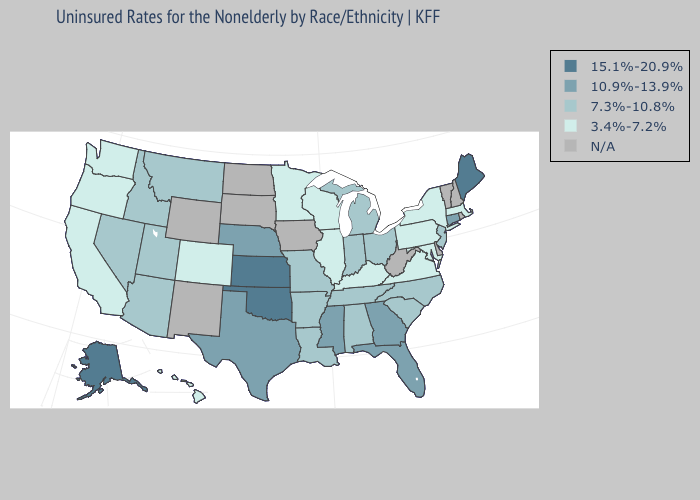Which states have the lowest value in the USA?
Keep it brief. California, Colorado, Hawaii, Illinois, Kentucky, Maryland, Massachusetts, Minnesota, New York, Oregon, Pennsylvania, Virginia, Washington, Wisconsin. Name the states that have a value in the range 7.3%-10.8%?
Write a very short answer. Alabama, Arizona, Arkansas, Idaho, Indiana, Louisiana, Michigan, Missouri, Montana, Nevada, New Jersey, North Carolina, Ohio, South Carolina, Tennessee, Utah. What is the highest value in the Northeast ?
Write a very short answer. 15.1%-20.9%. What is the value of California?
Concise answer only. 3.4%-7.2%. Does Connecticut have the highest value in the Northeast?
Keep it brief. No. Among the states that border New Mexico , does Utah have the lowest value?
Be succinct. No. What is the value of Alabama?
Short answer required. 7.3%-10.8%. Which states hav the highest value in the West?
Answer briefly. Alaska. What is the value of Minnesota?
Quick response, please. 3.4%-7.2%. What is the highest value in the USA?
Be succinct. 15.1%-20.9%. What is the highest value in the USA?
Answer briefly. 15.1%-20.9%. Does Massachusetts have the lowest value in the USA?
Concise answer only. Yes. 